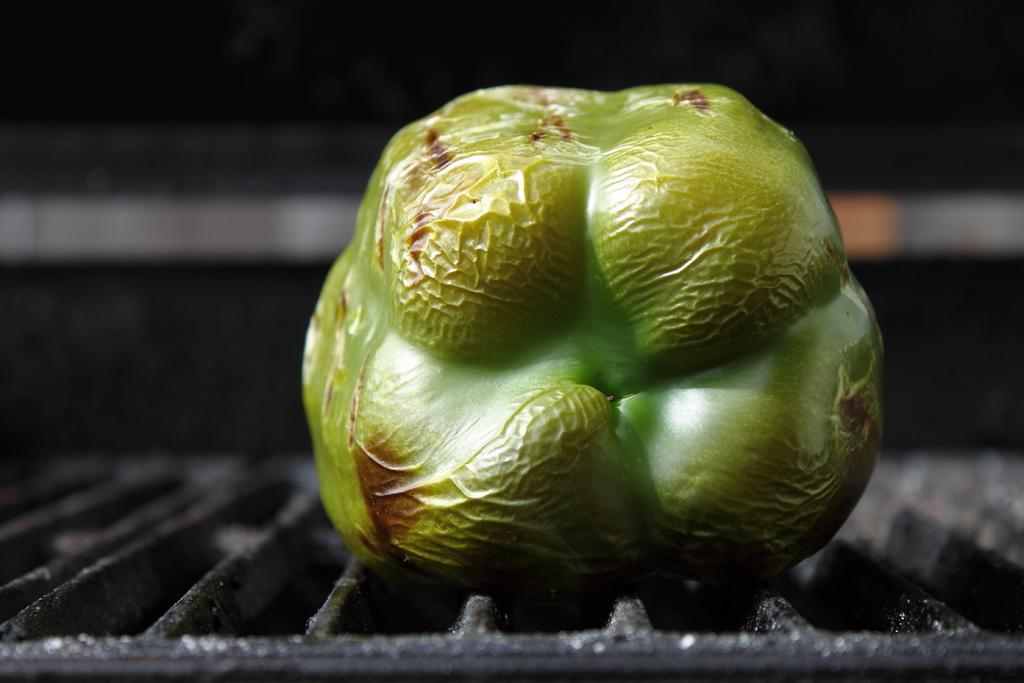What is the main subject of the image? The main subject of the image is a capsicum. Where is the capsicum located in the image? The capsicum is on a grille in the image. What can be observed about the background of the image? The background of the image is dark. What type of apparel is the capsicum wearing in the image? The capsicum is not wearing any apparel in the image, as it is a vegetable and not a person or an animal. 